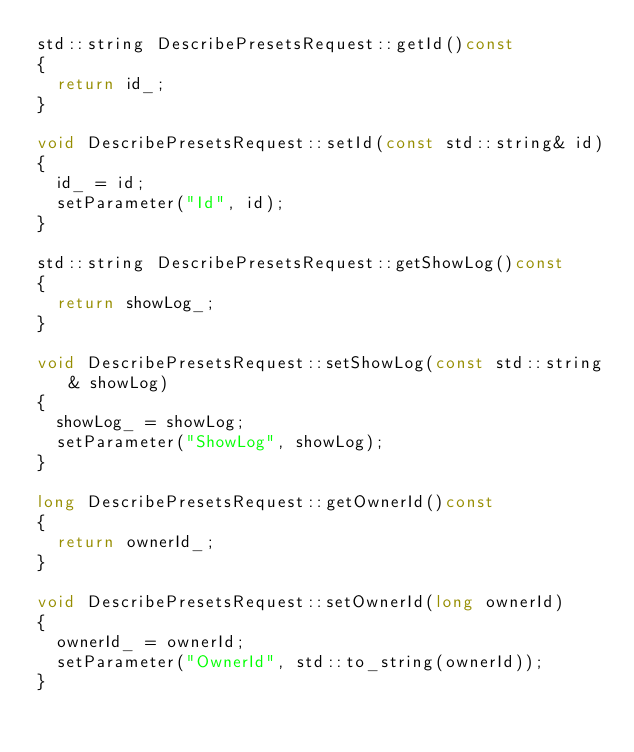Convert code to text. <code><loc_0><loc_0><loc_500><loc_500><_C++_>std::string DescribePresetsRequest::getId()const
{
	return id_;
}

void DescribePresetsRequest::setId(const std::string& id)
{
	id_ = id;
	setParameter("Id", id);
}

std::string DescribePresetsRequest::getShowLog()const
{
	return showLog_;
}

void DescribePresetsRequest::setShowLog(const std::string& showLog)
{
	showLog_ = showLog;
	setParameter("ShowLog", showLog);
}

long DescribePresetsRequest::getOwnerId()const
{
	return ownerId_;
}

void DescribePresetsRequest::setOwnerId(long ownerId)
{
	ownerId_ = ownerId;
	setParameter("OwnerId", std::to_string(ownerId));
}

</code> 